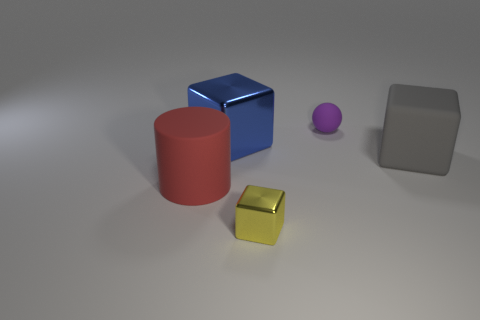Add 3 gray rubber blocks. How many objects exist? 8 Subtract all cylinders. How many objects are left? 4 Subtract all large gray cubes. Subtract all big yellow metallic cylinders. How many objects are left? 4 Add 1 matte blocks. How many matte blocks are left? 2 Add 3 large cubes. How many large cubes exist? 5 Subtract 0 blue cylinders. How many objects are left? 5 